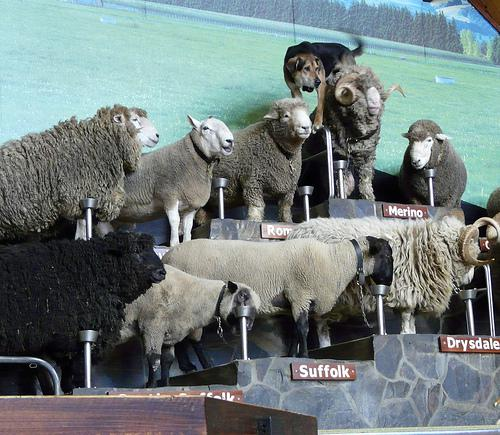Question: what are the sheep doing?
Choices:
A. Standing.
B. Running.
C. Grazing.
D. Laying.
Answer with the letter. Answer: A Question: what animals are in the photo?
Choices:
A. Cat and a mouse.
B. Cow and a chicken.
C. Sheep and a dog.
D. A pony and a goat.
Answer with the letter. Answer: C 